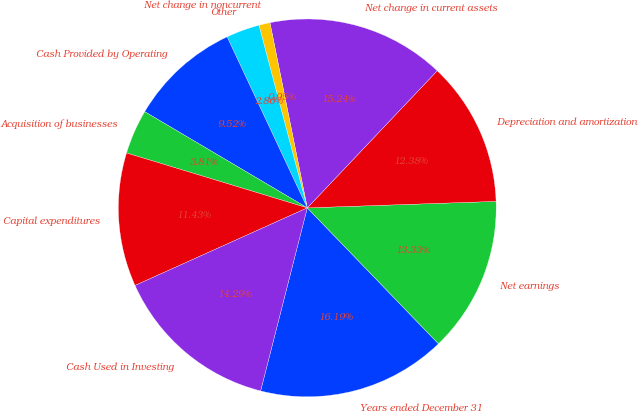Convert chart. <chart><loc_0><loc_0><loc_500><loc_500><pie_chart><fcel>Years ended December 31<fcel>Net earnings<fcel>Depreciation and amortization<fcel>Net change in current assets<fcel>Net change in noncurrent<fcel>Other<fcel>Cash Provided by Operating<fcel>Acquisition of businesses<fcel>Capital expenditures<fcel>Cash Used in Investing<nl><fcel>16.19%<fcel>13.33%<fcel>12.38%<fcel>15.24%<fcel>0.95%<fcel>2.86%<fcel>9.52%<fcel>3.81%<fcel>11.43%<fcel>14.29%<nl></chart> 